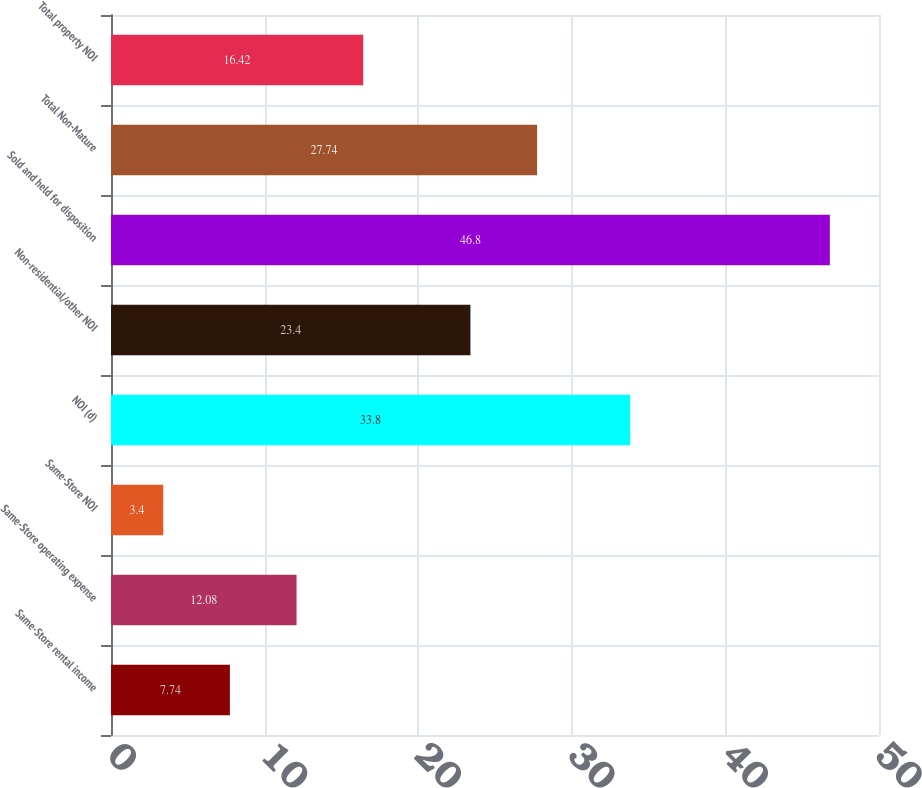Convert chart. <chart><loc_0><loc_0><loc_500><loc_500><bar_chart><fcel>Same-Store rental income<fcel>Same-Store operating expense<fcel>Same-Store NOI<fcel>NOI (d)<fcel>Non-residential/other NOI<fcel>Sold and held for disposition<fcel>Total Non-Mature<fcel>Total property NOI<nl><fcel>7.74<fcel>12.08<fcel>3.4<fcel>33.8<fcel>23.4<fcel>46.8<fcel>27.74<fcel>16.42<nl></chart> 